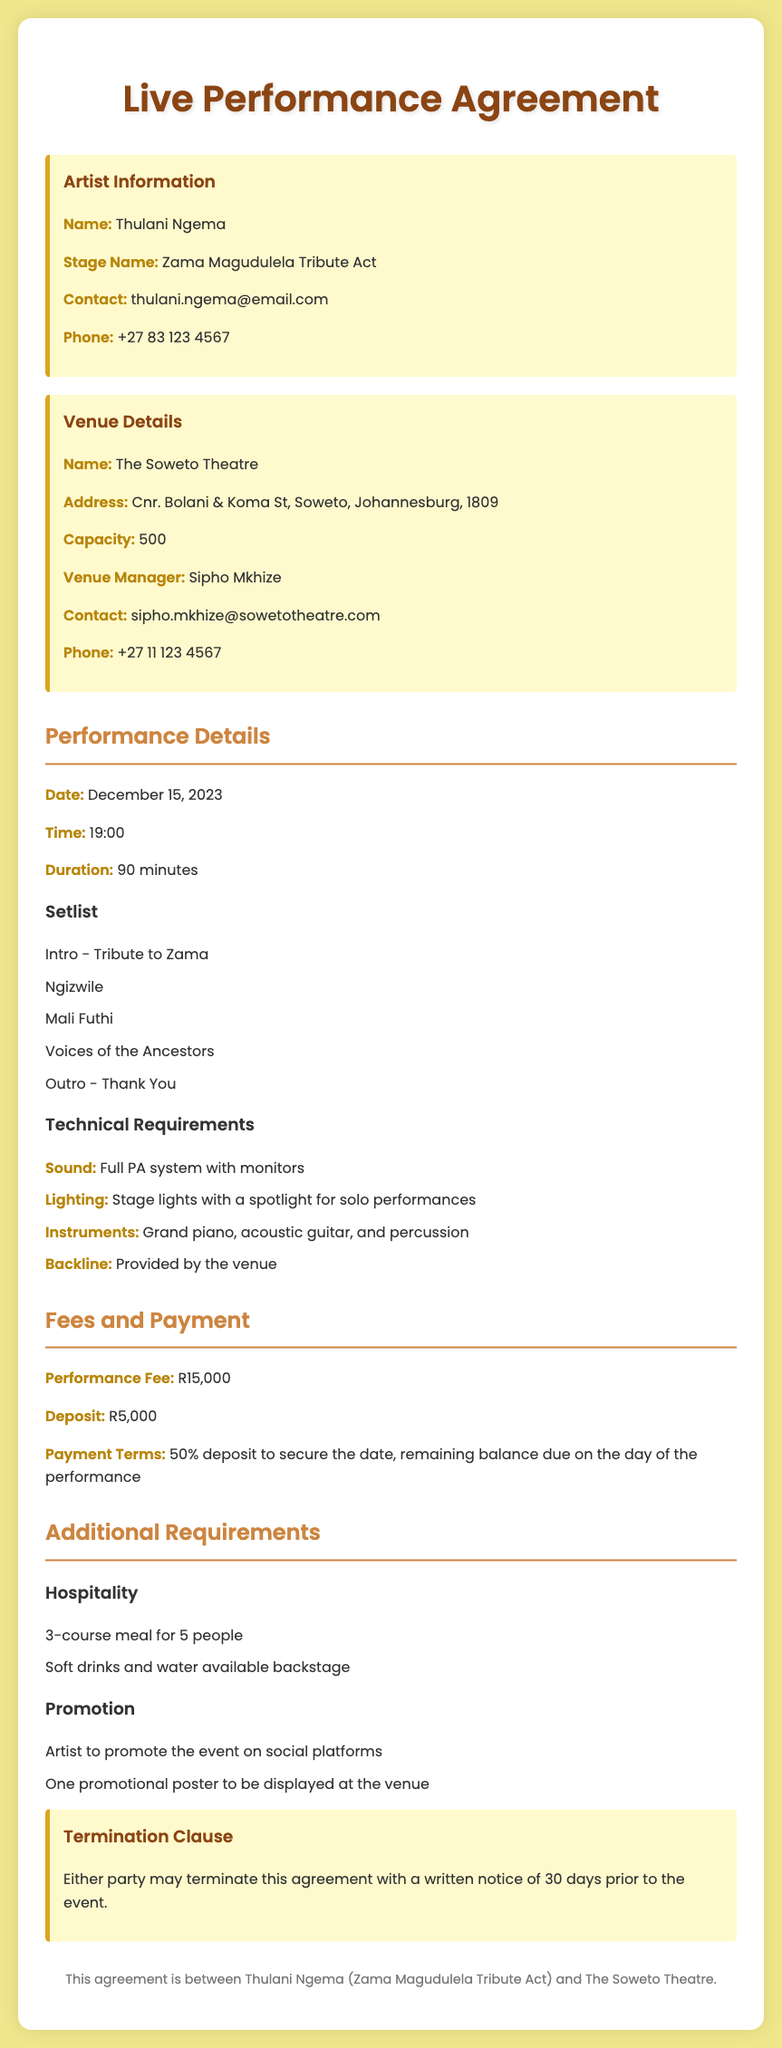What is the name of the artist? The name of the artist is Thulani Ngema as indicated in the artist information section.
Answer: Thulani Ngema What is the performance date? The performance date is specified in the performance details section of the document.
Answer: December 15, 2023 What is the venue name? The venue name is listed under the venue details section of the document.
Answer: The Soweto Theatre What is the capacity of the venue? The capacity of the venue is mentioned in the venue details section.
Answer: 500 What is the performance fee? The performance fee is specified in the fees and payment section of the document.
Answer: R15,000 What are the technical requirements for sound? The document lists sound requirements under the technical requirements section.
Answer: Full PA system with monitors What is the deposit amount? The deposit amount is included in the fees and payment section of the document.
Answer: R5,000 What is required for hospitality? Hospitality requirements are outlined in the additional requirements section of the document.
Answer: 3-course meal for 5 people What must the artist do for promotion? The promotion requirements are mentioned in the additional requirements section.
Answer: Artist to promote the event on social platforms What is the termination notice period? The termination notice period is stated in the termination clause of the document.
Answer: 30 days 